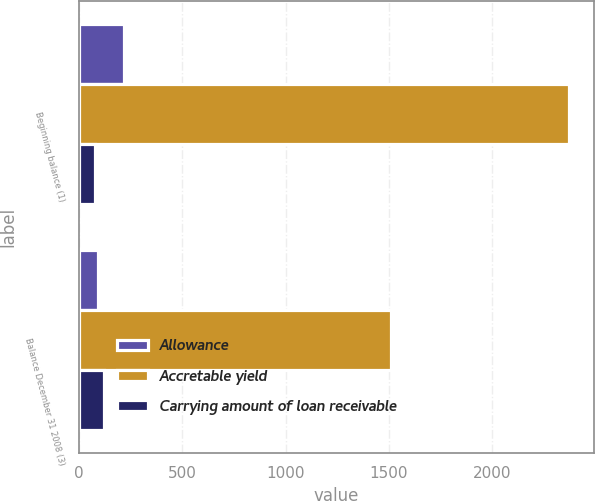<chart> <loc_0><loc_0><loc_500><loc_500><stacked_bar_chart><ecel><fcel>Beginning balance (1)<fcel>Balance December 31 2008 (3)<nl><fcel>Allowance<fcel>219<fcel>92<nl><fcel>Accretable yield<fcel>2373<fcel>1510<nl><fcel>Carrying amount of loan receivable<fcel>76<fcel>122<nl></chart> 